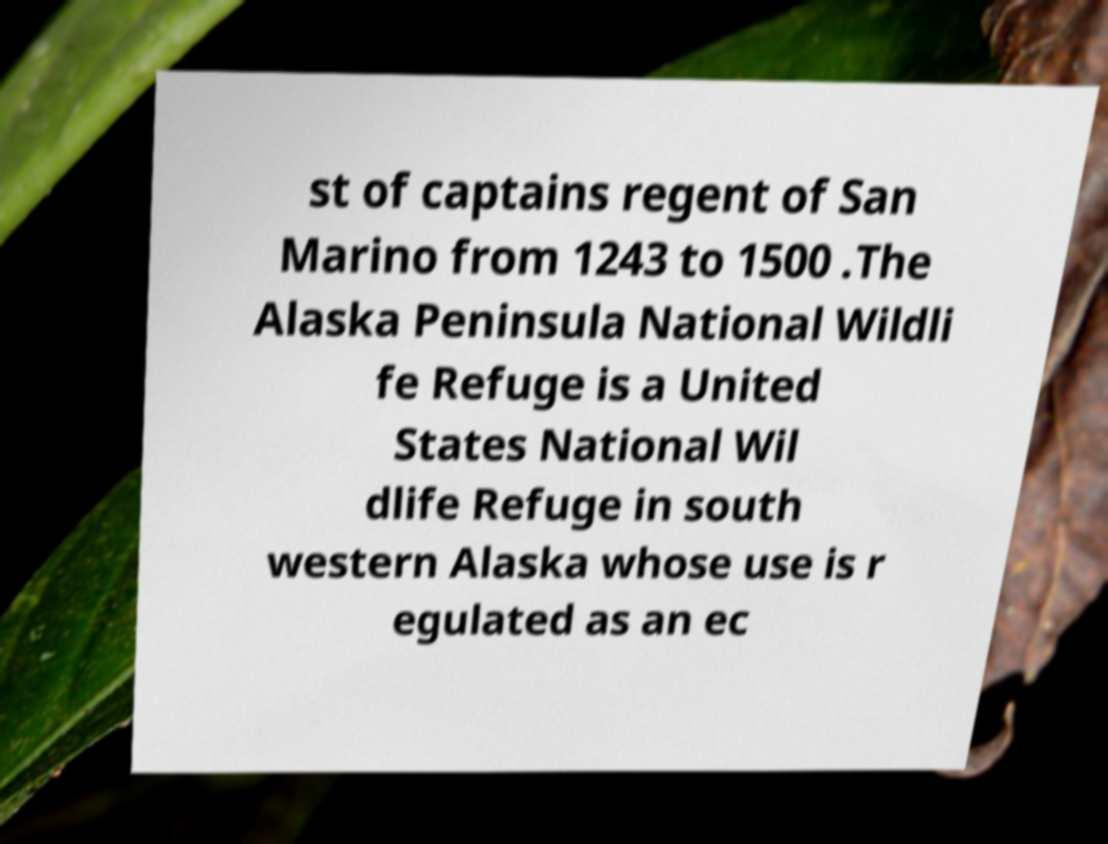What messages or text are displayed in this image? I need them in a readable, typed format. st of captains regent of San Marino from 1243 to 1500 .The Alaska Peninsula National Wildli fe Refuge is a United States National Wil dlife Refuge in south western Alaska whose use is r egulated as an ec 